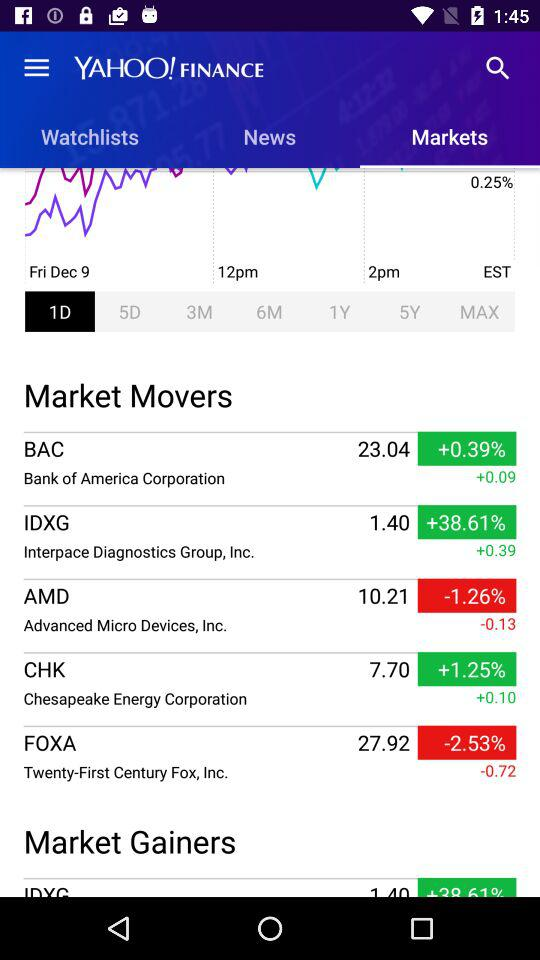Which tab is currently selected? The currently selected tabs are "Markets" and "1D". 